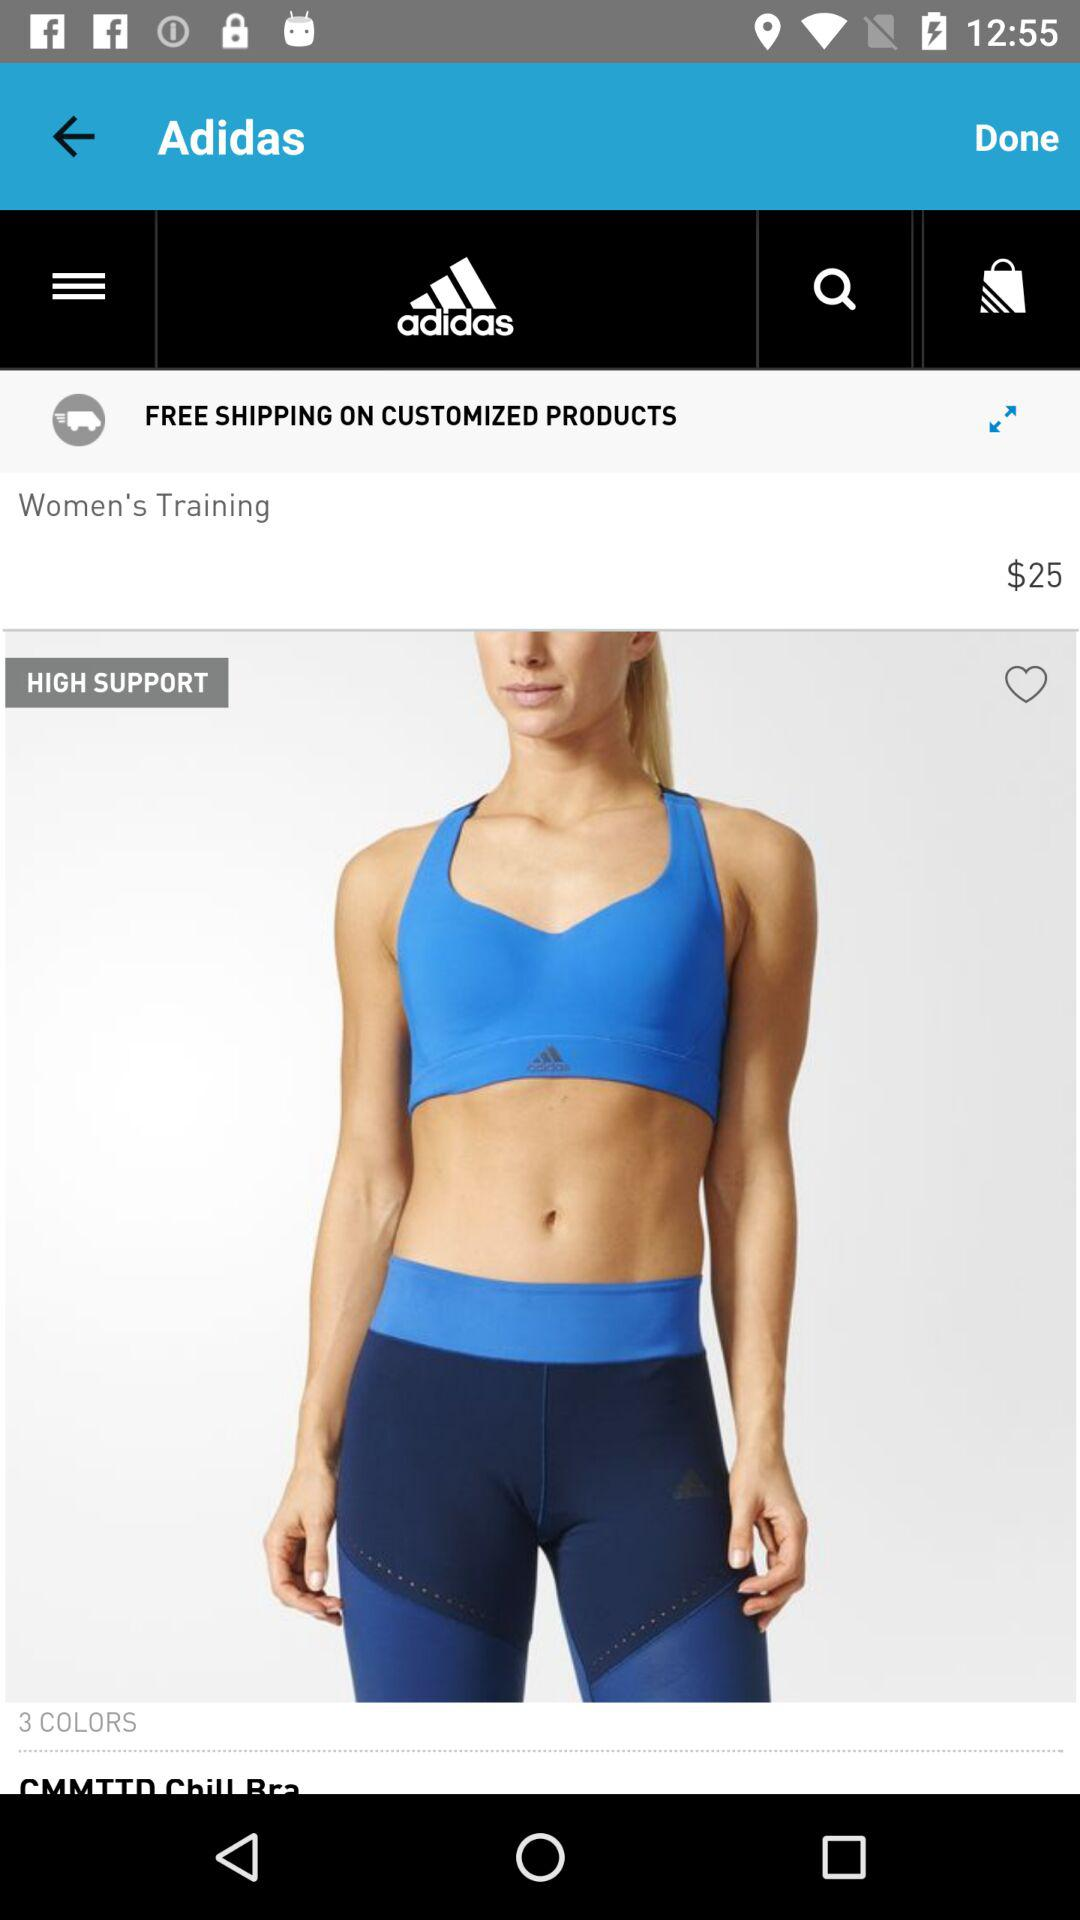How many colors are available for the CMMTTD Chill Bra?
Answer the question using a single word or phrase. 3 